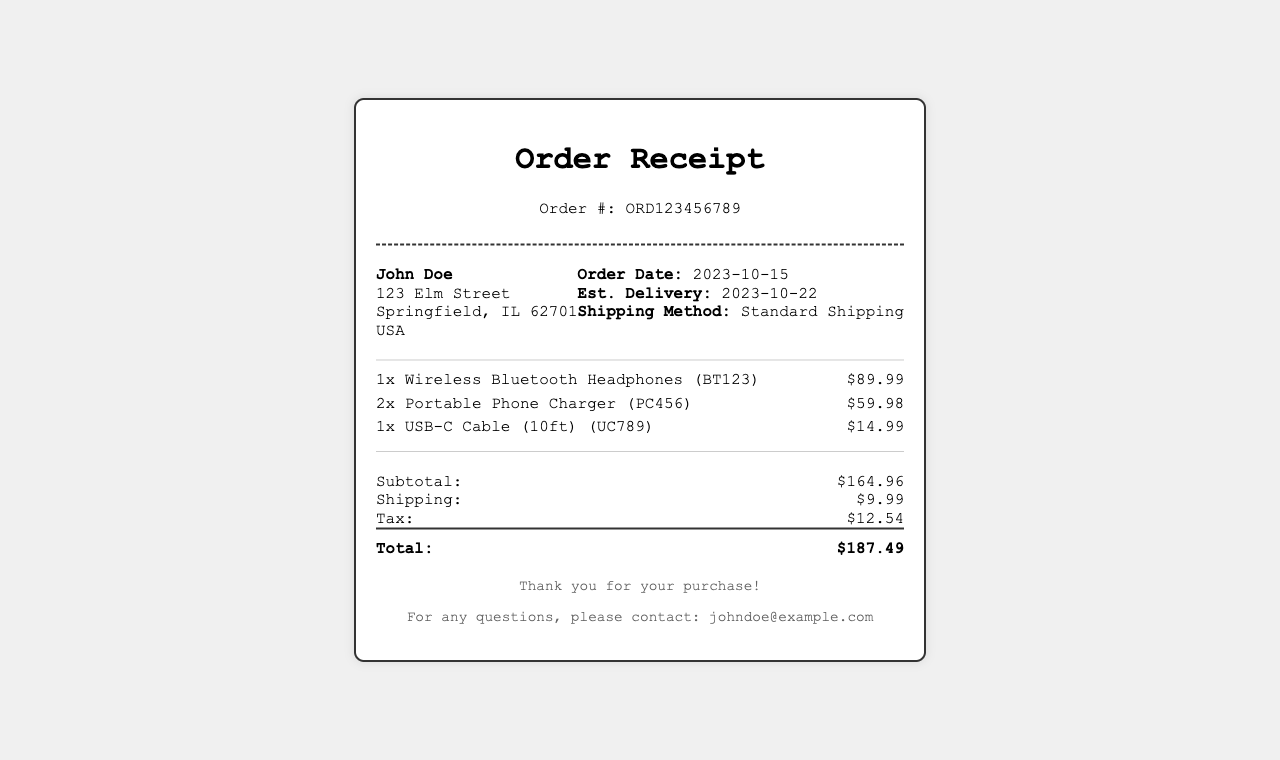What is the order number? The order number is provided at the top of the receipt as a unique identifier for the transaction.
Answer: ORD123456789 What is the estimated delivery date? The estimated delivery date is stated in the order information section of the receipt.
Answer: 2023-10-22 How many Portable Phone Chargers were purchased? The quantity of Portable Phone Chargers listed in the items section allows for an easy retrieval of this information.
Answer: 2x What is the subtotal amount? The subtotal is calculated as the sum of all items before any additional charges. It's displayed in the totals section.
Answer: $164.96 What shipping method was used? The shipping method is mentioned in the order information and provides details on how the items are being sent.
Answer: Standard Shipping What is the total amount charged? The total amount charged is found at the bottom of the totals section, representing the final cost after shipping and tax.
Answer: $187.49 Who is the customer? The customer's name is prominently displayed at the top of the order information.
Answer: John Doe What is the email address for customer support? The email address for any inquiries is included in the footer of the receipt for customer assistance.
Answer: johndoe@example.com What is the tax amount? The tax amount is explicitly stated under the totals section, showing the tax applied to the purchase.
Answer: $12.54 